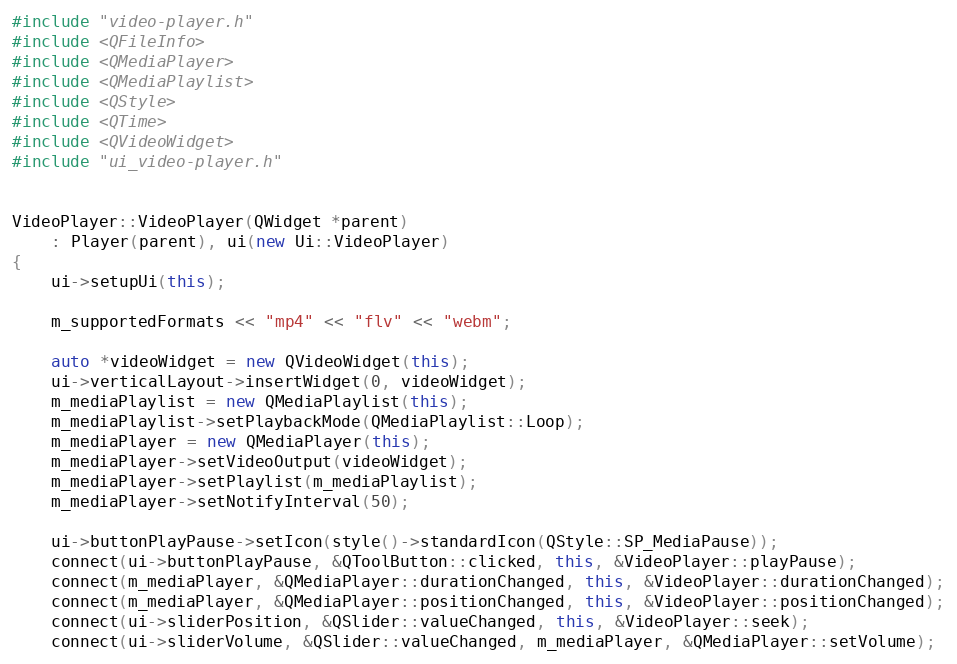Convert code to text. <code><loc_0><loc_0><loc_500><loc_500><_C++_>#include "video-player.h"
#include <QFileInfo>
#include <QMediaPlayer>
#include <QMediaPlaylist>
#include <QStyle>
#include <QTime>
#include <QVideoWidget>
#include "ui_video-player.h"


VideoPlayer::VideoPlayer(QWidget *parent)
	: Player(parent), ui(new Ui::VideoPlayer)
{
	ui->setupUi(this);

	m_supportedFormats << "mp4" << "flv" << "webm";

	auto *videoWidget = new QVideoWidget(this);
	ui->verticalLayout->insertWidget(0, videoWidget);
	m_mediaPlaylist = new QMediaPlaylist(this);
	m_mediaPlaylist->setPlaybackMode(QMediaPlaylist::Loop);
	m_mediaPlayer = new QMediaPlayer(this);
	m_mediaPlayer->setVideoOutput(videoWidget);
	m_mediaPlayer->setPlaylist(m_mediaPlaylist);
	m_mediaPlayer->setNotifyInterval(50);

	ui->buttonPlayPause->setIcon(style()->standardIcon(QStyle::SP_MediaPause));
	connect(ui->buttonPlayPause, &QToolButton::clicked, this, &VideoPlayer::playPause);
	connect(m_mediaPlayer, &QMediaPlayer::durationChanged, this, &VideoPlayer::durationChanged);
	connect(m_mediaPlayer, &QMediaPlayer::positionChanged, this, &VideoPlayer::positionChanged);
	connect(ui->sliderPosition, &QSlider::valueChanged, this, &VideoPlayer::seek);
	connect(ui->sliderVolume, &QSlider::valueChanged, m_mediaPlayer, &QMediaPlayer::setVolume);</code> 